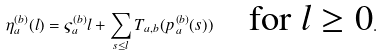<formula> <loc_0><loc_0><loc_500><loc_500>\eta _ { a } ^ { ( b ) } ( l ) = \varsigma _ { a } ^ { ( b ) } l + \sum _ { s \leq l } T _ { a , b } ( p _ { a } ^ { ( b ) } ( s ) ) \quad \text {for $ l \geq 0 $} .</formula> 